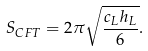Convert formula to latex. <formula><loc_0><loc_0><loc_500><loc_500>S _ { C F T } = 2 \pi \sqrt { \frac { c _ { L } h _ { L } } 6 } .</formula> 